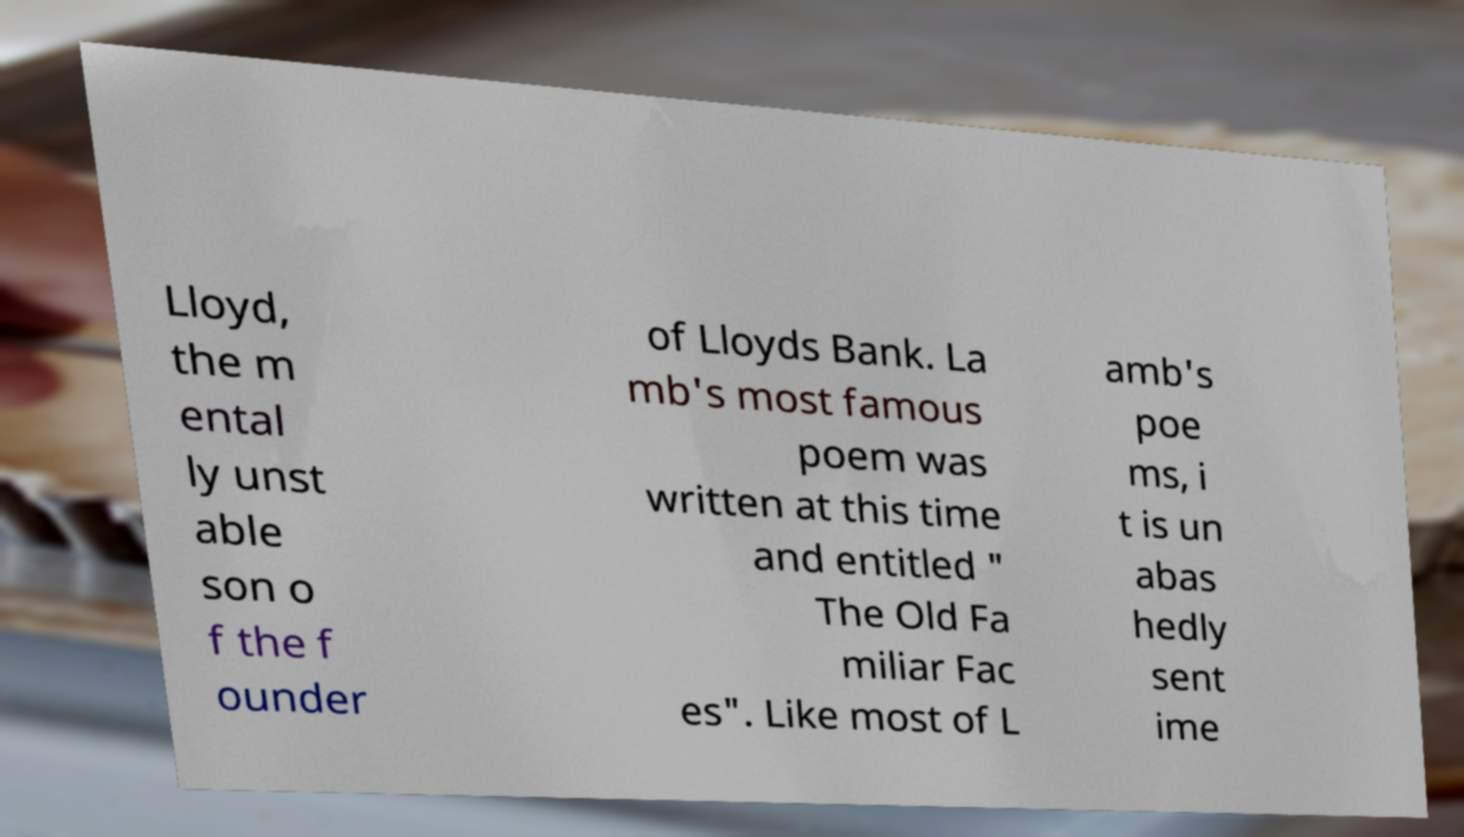Please identify and transcribe the text found in this image. Lloyd, the m ental ly unst able son o f the f ounder of Lloyds Bank. La mb's most famous poem was written at this time and entitled " The Old Fa miliar Fac es". Like most of L amb's poe ms, i t is un abas hedly sent ime 